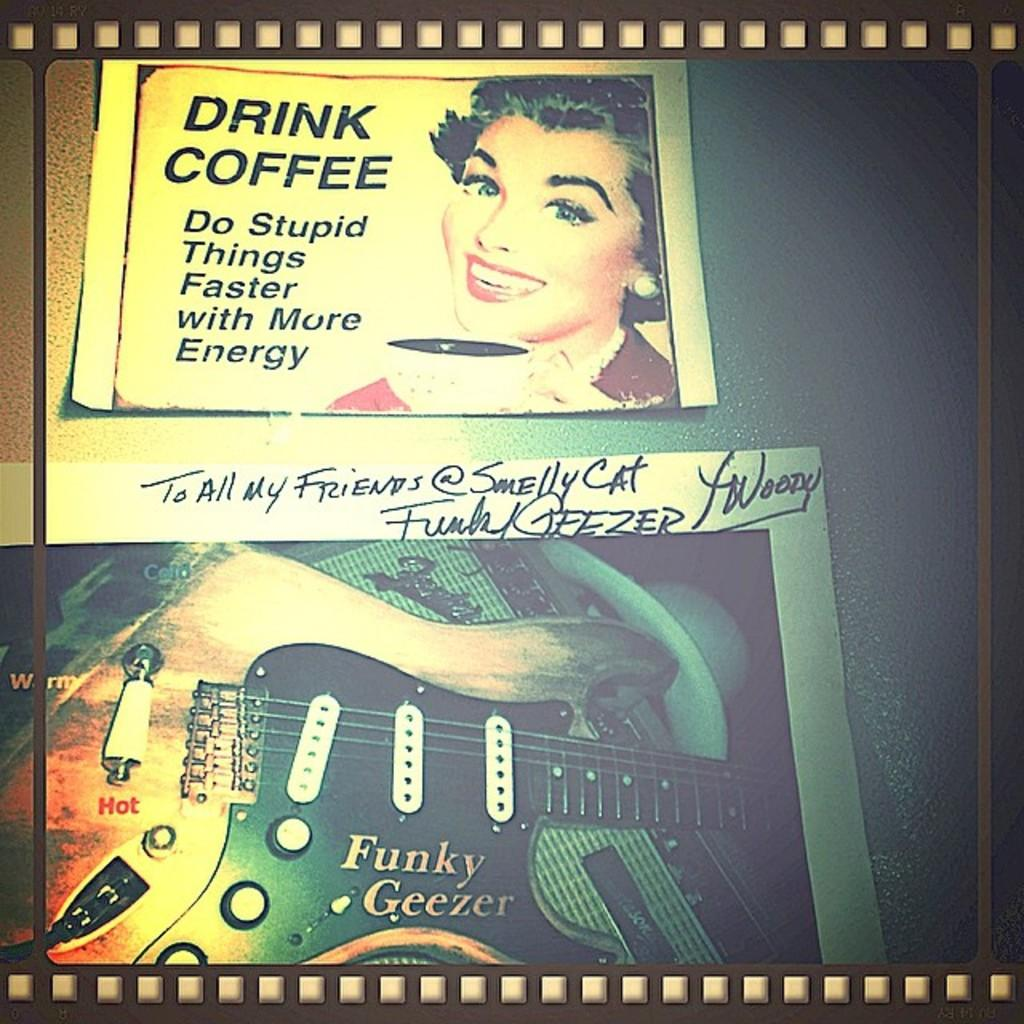What can be seen on the wall in the image? There are posters on the wall in the image. Can you describe the posters in more detail? Unfortunately, the provided facts do not give any additional details about the posters. Are there any other objects or features visible in the image? The provided facts only mention the posters on the wall, so we cannot comment on any other objects or features. What type of silk is used to make the ear visible in the image? There is no ear or silk present in the image; it only features posters on the wall. 